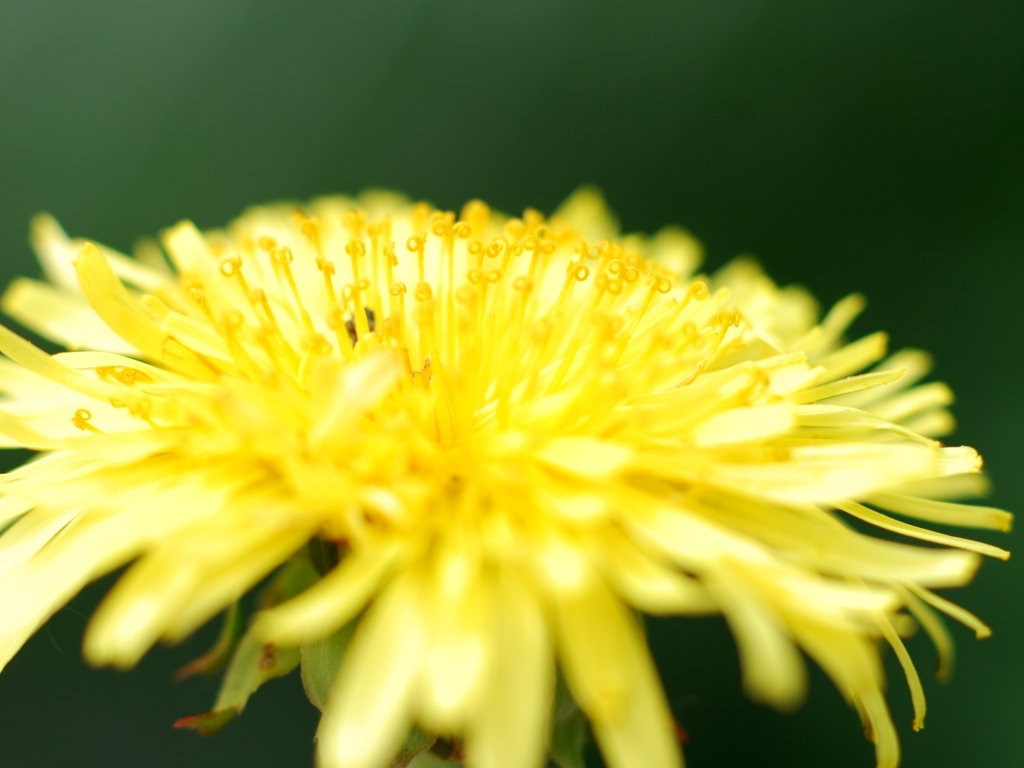How might this flower change as the seasons progress? As the seasons change, the dandelion will undergo a transformation. After blooming and the pollination process, the yellow petals will give way to a ball of fluffy, white seed heads, commonly known as the dandelion clock. These seed heads will disperse in the wind, allowing the dandelion to propagate its seeds over a wide area, ensuring its survival and colonizing new environments through the course of the seasons. 